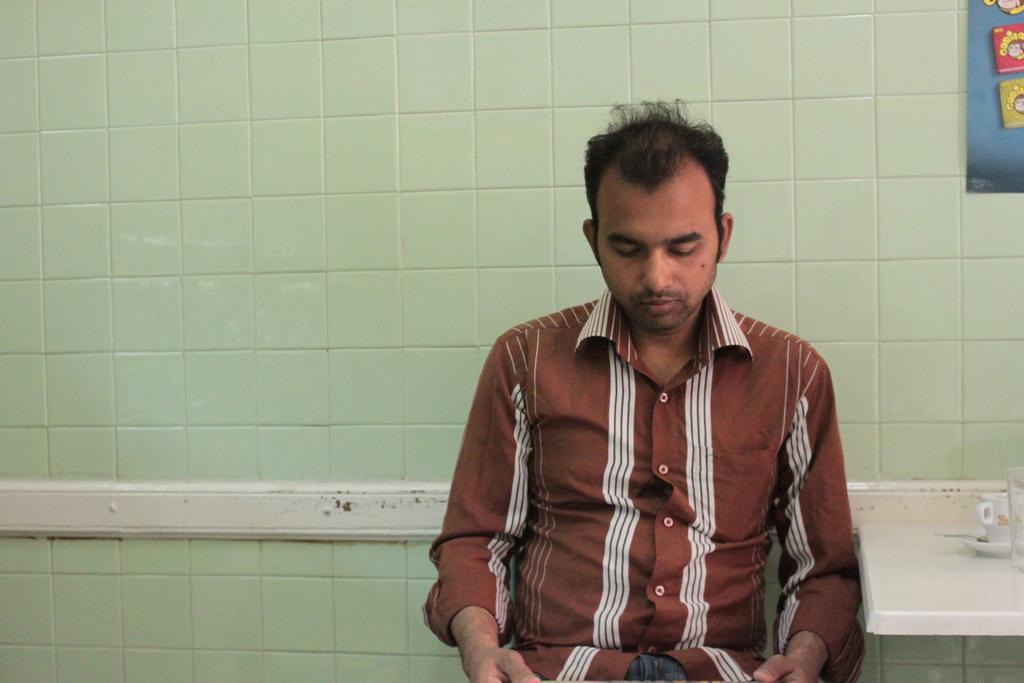Can you describe this image briefly? The man in the brown shirt is sitting and he is looking at something. Beside him, we see a white table on which cup, saucer and glass are placed. Behind him, we see a wall which is in white ad green color. In the right top of the picture, we see a blue color board on which posters are pasted. 